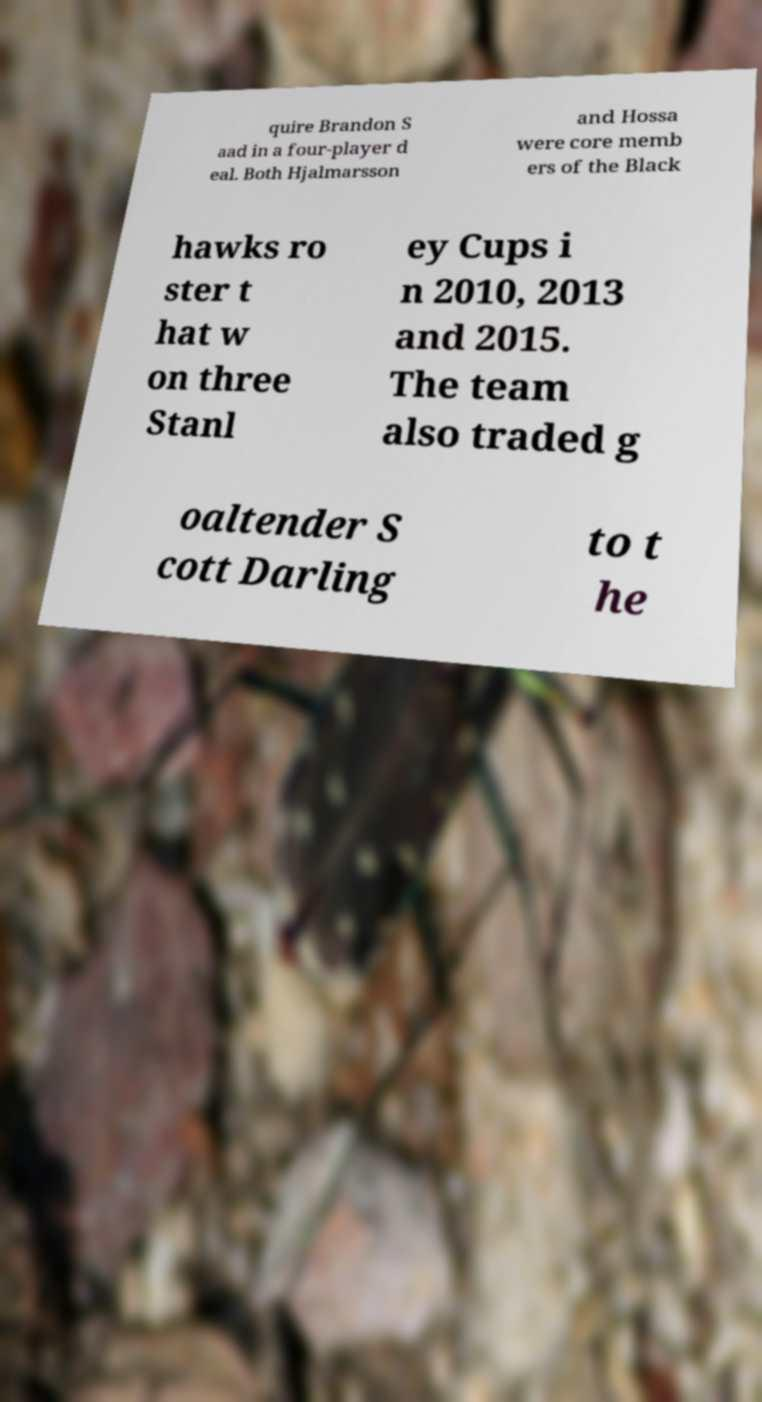Can you read and provide the text displayed in the image?This photo seems to have some interesting text. Can you extract and type it out for me? quire Brandon S aad in a four-player d eal. Both Hjalmarsson and Hossa were core memb ers of the Black hawks ro ster t hat w on three Stanl ey Cups i n 2010, 2013 and 2015. The team also traded g oaltender S cott Darling to t he 